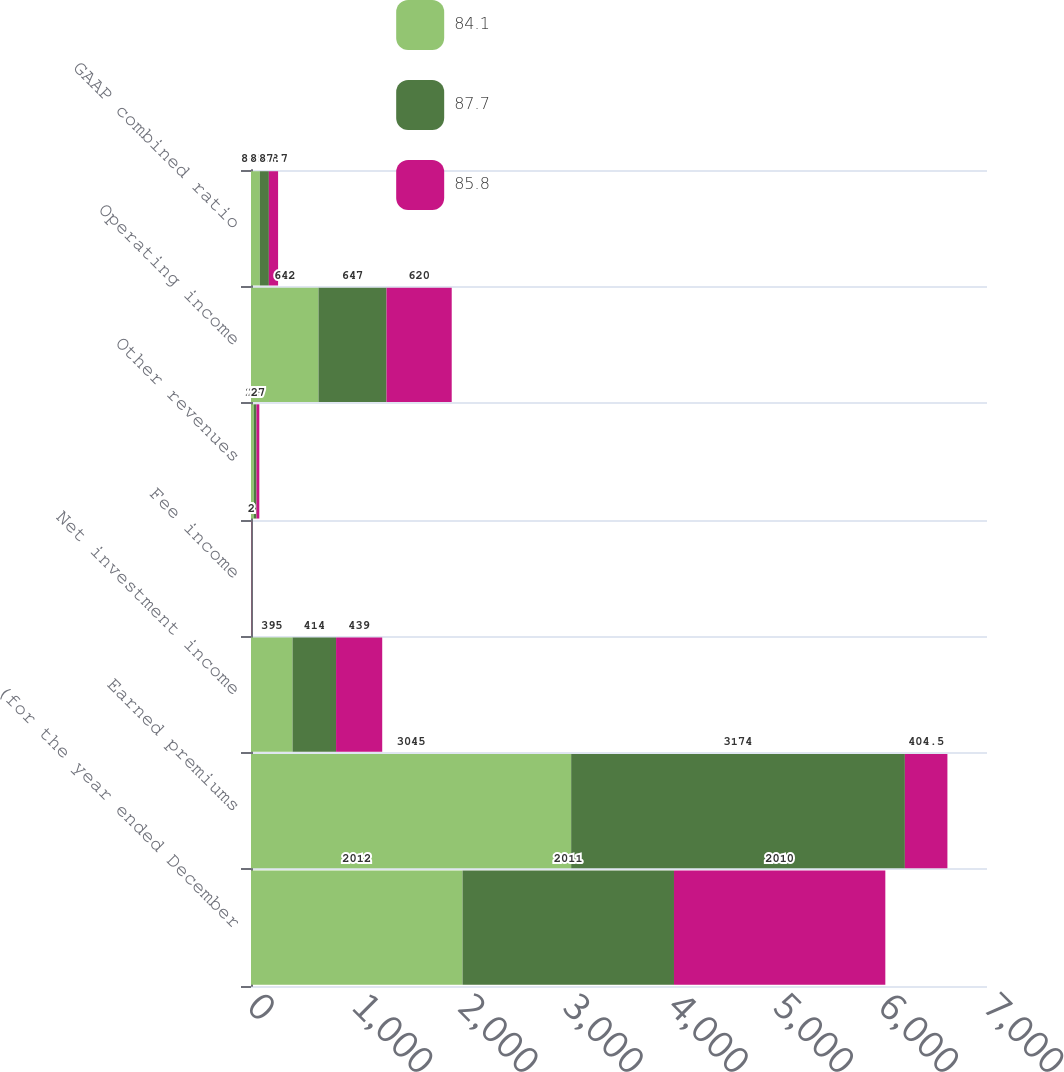<chart> <loc_0><loc_0><loc_500><loc_500><stacked_bar_chart><ecel><fcel>(for the year ended December<fcel>Earned premiums<fcel>Net investment income<fcel>Fee income<fcel>Other revenues<fcel>Operating income<fcel>GAAP combined ratio<nl><fcel>84.1<fcel>2012<fcel>3045<fcel>395<fcel>1<fcel>26<fcel>642<fcel>84.1<nl><fcel>87.7<fcel>2011<fcel>3174<fcel>414<fcel>1<fcel>26<fcel>647<fcel>85.8<nl><fcel>85.8<fcel>2010<fcel>404.5<fcel>439<fcel>2<fcel>27<fcel>620<fcel>87.7<nl></chart> 